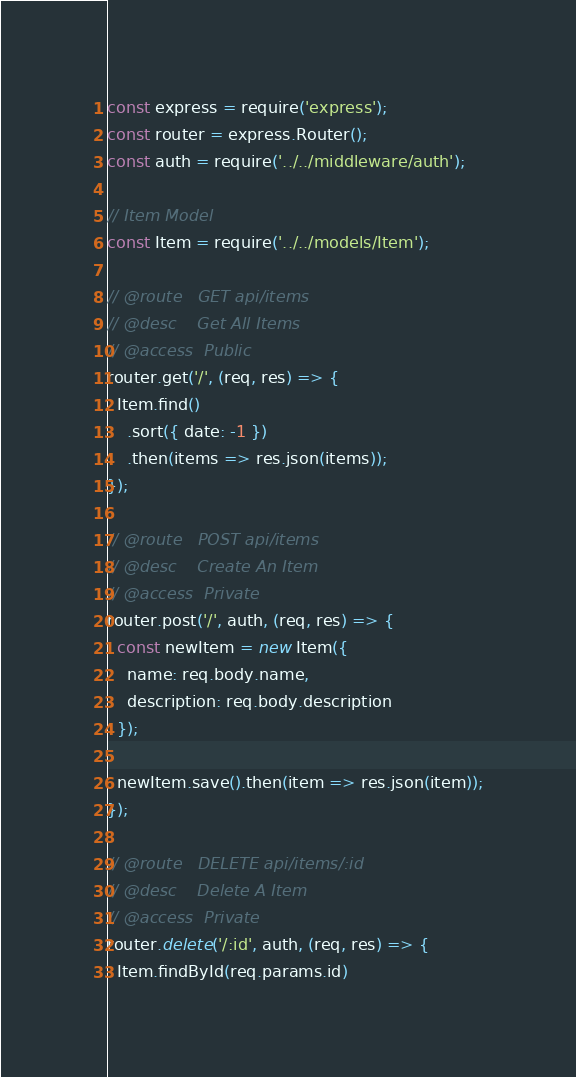Convert code to text. <code><loc_0><loc_0><loc_500><loc_500><_JavaScript_>const express = require('express');
const router = express.Router();
const auth = require('../../middleware/auth');

// Item Model
const Item = require('../../models/Item');

// @route   GET api/items
// @desc    Get All Items
// @access  Public
router.get('/', (req, res) => {
  Item.find()
    .sort({ date: -1 })
    .then(items => res.json(items));
});

// @route   POST api/items
// @desc    Create An Item
// @access  Private
router.post('/', auth, (req, res) => {
  const newItem = new Item({
    name: req.body.name,
    description: req.body.description
  });

  newItem.save().then(item => res.json(item));
});

// @route   DELETE api/items/:id
// @desc    Delete A Item
// @access  Private
router.delete('/:id', auth, (req, res) => {
  Item.findById(req.params.id)</code> 